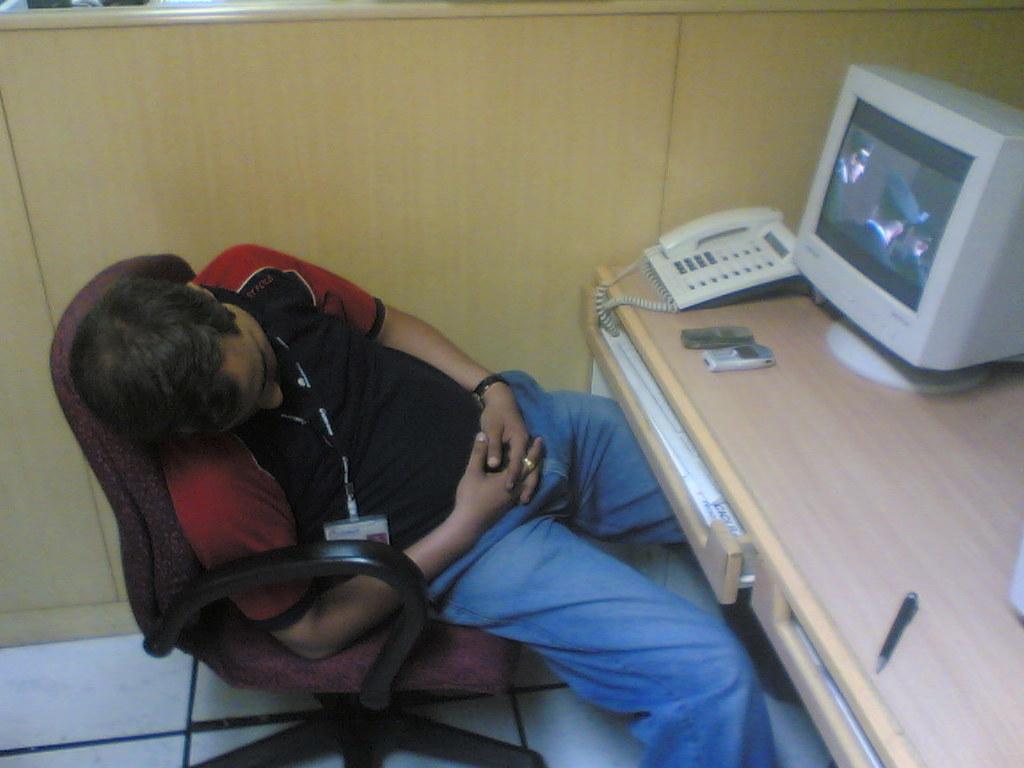Can you describe this image briefly? This image consist of a man sleeping in a chair. He is wearing blue jeans. In front of him there is a desk on which a monitor, telephone and mobiles are kept. In the background, there is a wooden wall. At the bottom, there is a floor. 